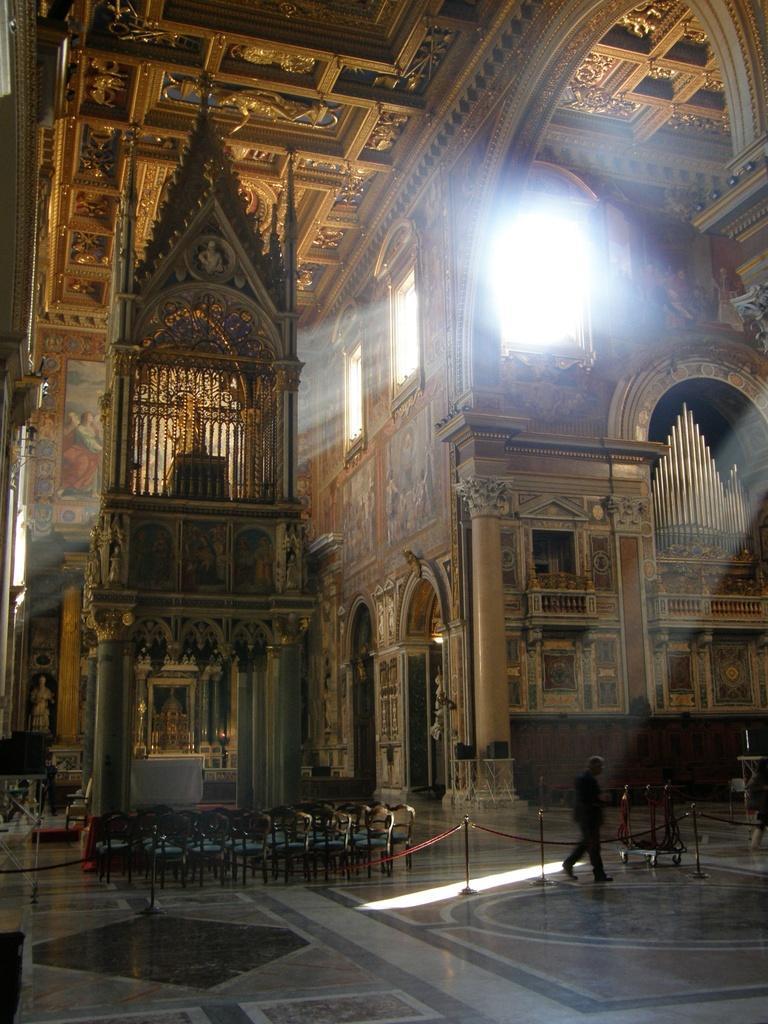Describe this image in one or two sentences. This picture describes about inside view of a building, in this we can find few chairs, metal rods, cables, lights and a person, in the background we can see a statue and painting on the wall. 